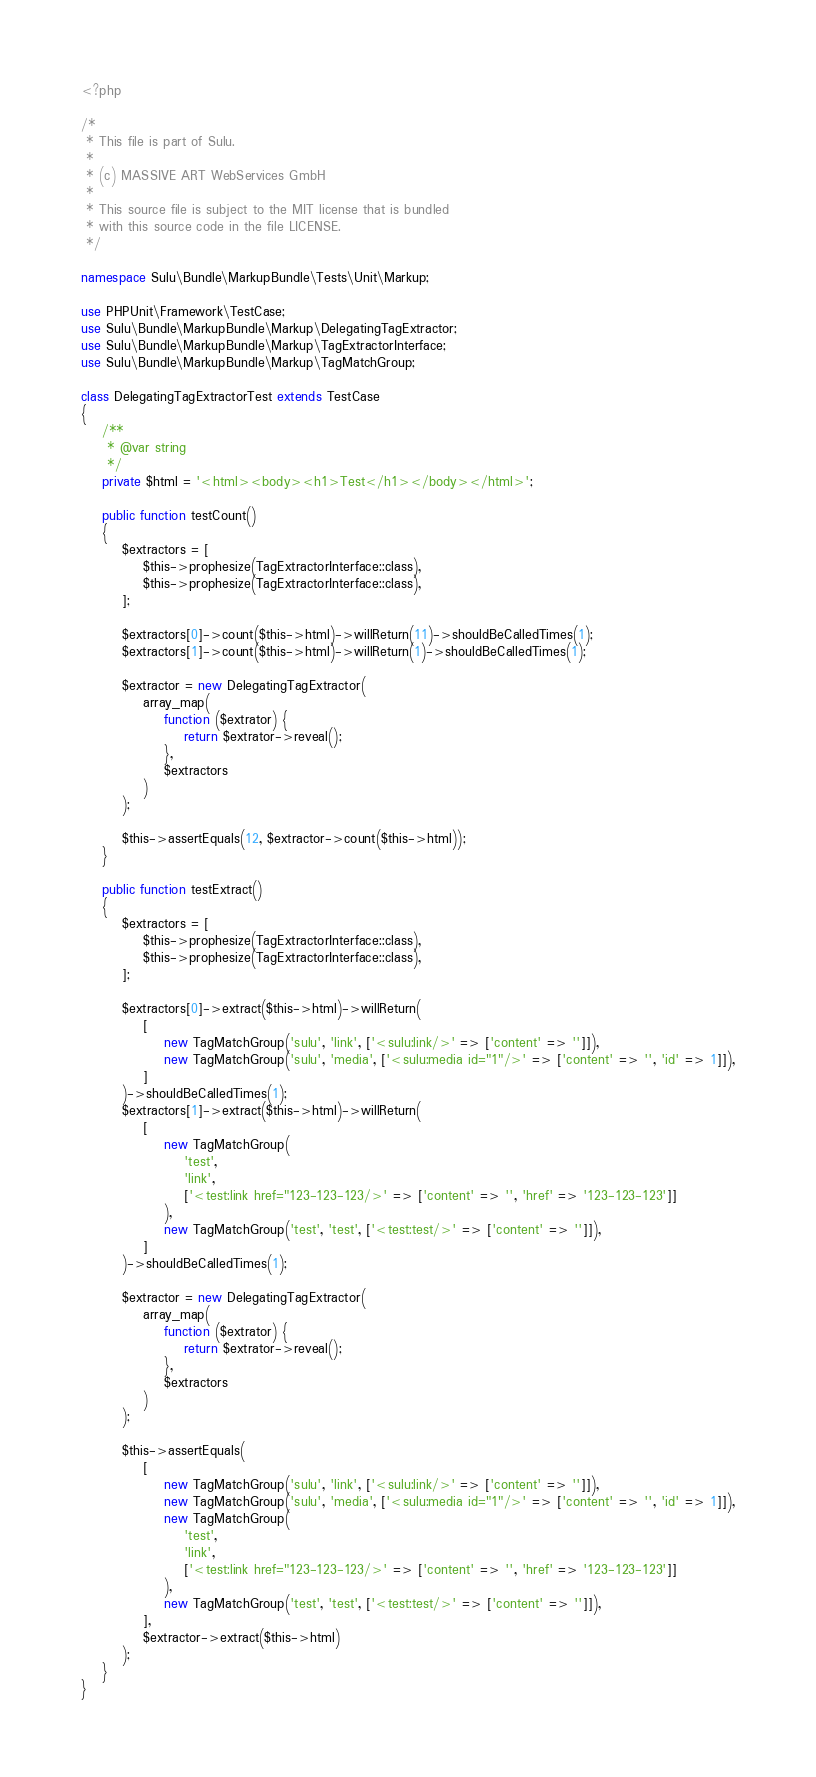<code> <loc_0><loc_0><loc_500><loc_500><_PHP_><?php

/*
 * This file is part of Sulu.
 *
 * (c) MASSIVE ART WebServices GmbH
 *
 * This source file is subject to the MIT license that is bundled
 * with this source code in the file LICENSE.
 */

namespace Sulu\Bundle\MarkupBundle\Tests\Unit\Markup;

use PHPUnit\Framework\TestCase;
use Sulu\Bundle\MarkupBundle\Markup\DelegatingTagExtractor;
use Sulu\Bundle\MarkupBundle\Markup\TagExtractorInterface;
use Sulu\Bundle\MarkupBundle\Markup\TagMatchGroup;

class DelegatingTagExtractorTest extends TestCase
{
    /**
     * @var string
     */
    private $html = '<html><body><h1>Test</h1></body></html>';

    public function testCount()
    {
        $extractors = [
            $this->prophesize(TagExtractorInterface::class),
            $this->prophesize(TagExtractorInterface::class),
        ];

        $extractors[0]->count($this->html)->willReturn(11)->shouldBeCalledTimes(1);
        $extractors[1]->count($this->html)->willReturn(1)->shouldBeCalledTimes(1);

        $extractor = new DelegatingTagExtractor(
            array_map(
                function ($extrator) {
                    return $extrator->reveal();
                },
                $extractors
            )
        );

        $this->assertEquals(12, $extractor->count($this->html));
    }

    public function testExtract()
    {
        $extractors = [
            $this->prophesize(TagExtractorInterface::class),
            $this->prophesize(TagExtractorInterface::class),
        ];

        $extractors[0]->extract($this->html)->willReturn(
            [
                new TagMatchGroup('sulu', 'link', ['<sulu:link/>' => ['content' => '']]),
                new TagMatchGroup('sulu', 'media', ['<sulu:media id="1"/>' => ['content' => '', 'id' => 1]]),
            ]
        )->shouldBeCalledTimes(1);
        $extractors[1]->extract($this->html)->willReturn(
            [
                new TagMatchGroup(
                    'test',
                    'link',
                    ['<test:link href="123-123-123/>' => ['content' => '', 'href' => '123-123-123']]
                ),
                new TagMatchGroup('test', 'test', ['<test:test/>' => ['content' => '']]),
            ]
        )->shouldBeCalledTimes(1);

        $extractor = new DelegatingTagExtractor(
            array_map(
                function ($extrator) {
                    return $extrator->reveal();
                },
                $extractors
            )
        );

        $this->assertEquals(
            [
                new TagMatchGroup('sulu', 'link', ['<sulu:link/>' => ['content' => '']]),
                new TagMatchGroup('sulu', 'media', ['<sulu:media id="1"/>' => ['content' => '', 'id' => 1]]),
                new TagMatchGroup(
                    'test',
                    'link',
                    ['<test:link href="123-123-123/>' => ['content' => '', 'href' => '123-123-123']]
                ),
                new TagMatchGroup('test', 'test', ['<test:test/>' => ['content' => '']]),
            ],
            $extractor->extract($this->html)
        );
    }
}
</code> 